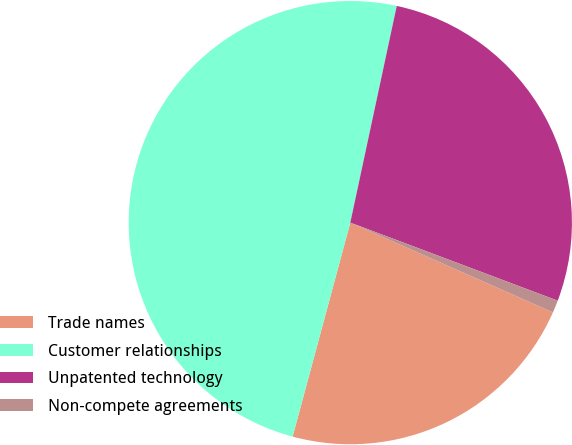Convert chart to OTSL. <chart><loc_0><loc_0><loc_500><loc_500><pie_chart><fcel>Trade names<fcel>Customer relationships<fcel>Unpatented technology<fcel>Non-compete agreements<nl><fcel>22.55%<fcel>49.17%<fcel>27.37%<fcel>0.91%<nl></chart> 